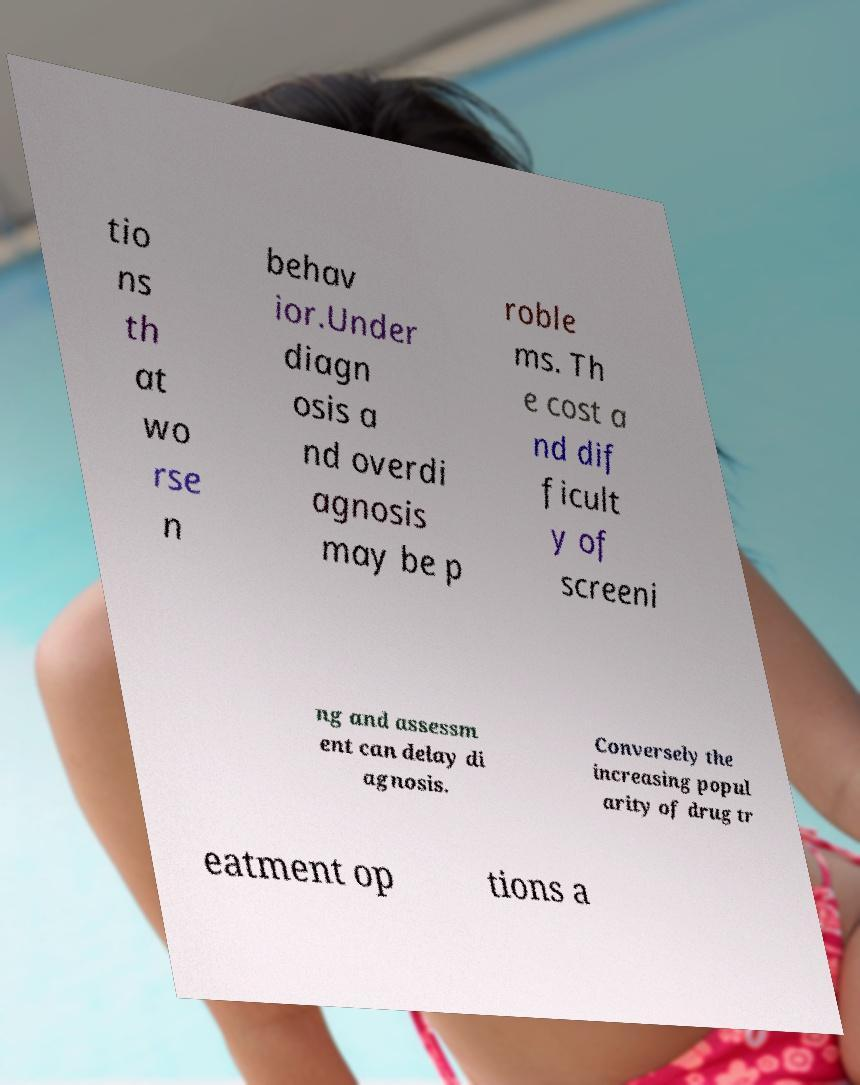What messages or text are displayed in this image? I need them in a readable, typed format. tio ns th at wo rse n behav ior.Under diagn osis a nd overdi agnosis may be p roble ms. Th e cost a nd dif ficult y of screeni ng and assessm ent can delay di agnosis. Conversely the increasing popul arity of drug tr eatment op tions a 